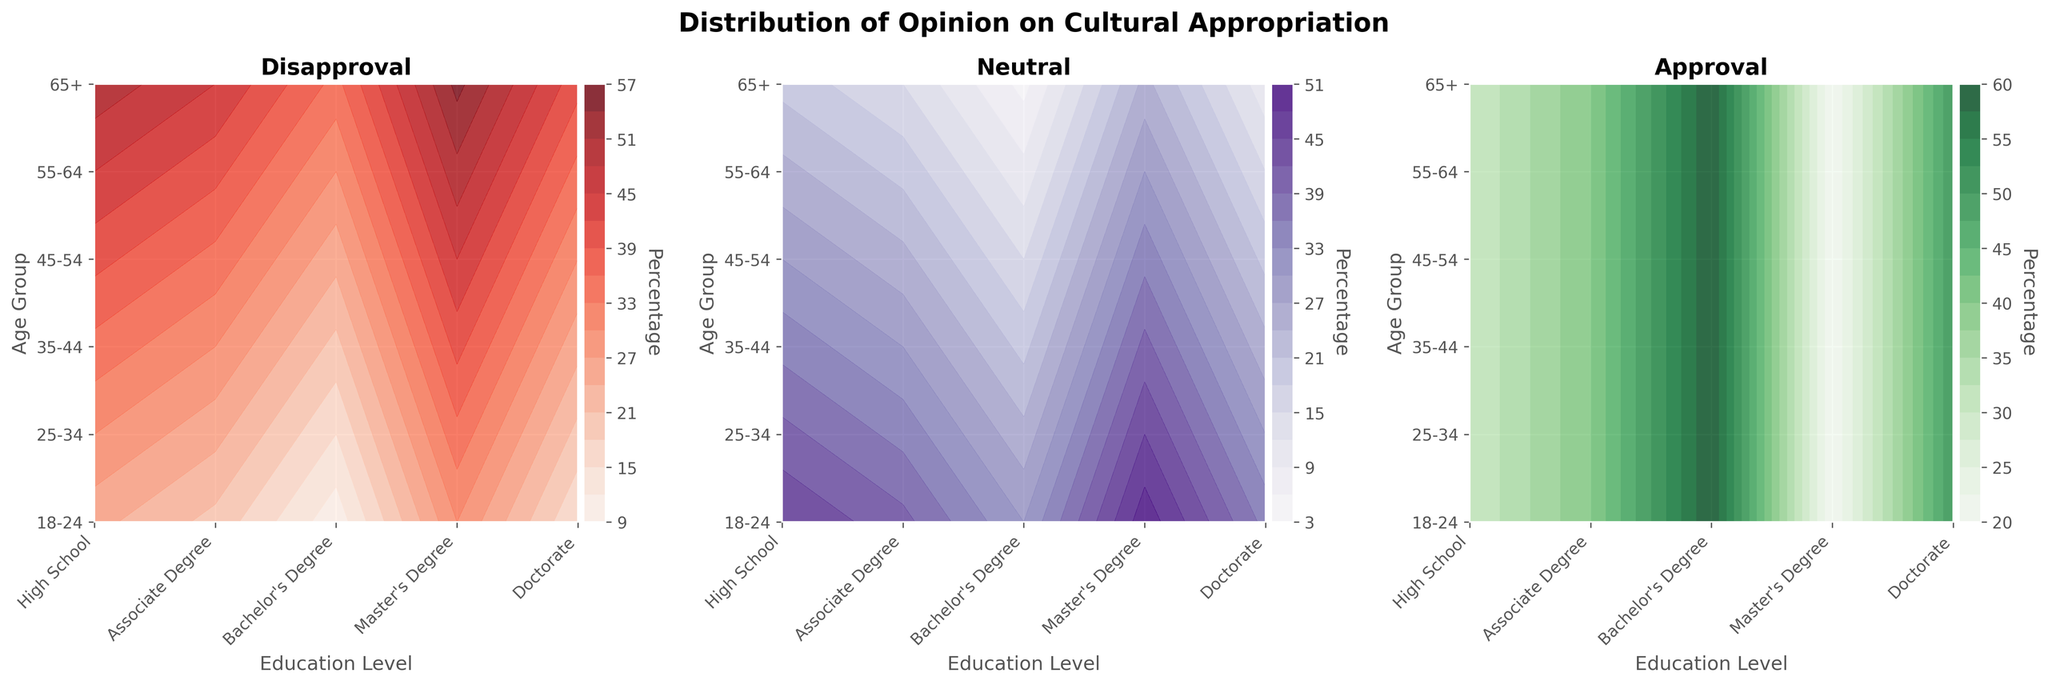What are the three opinions shown in the contour plots? The titles of the subplots indicate that there are three opinions: 'Disapproval', 'Neutral', and 'Approval'. You can see the titles at the top of each subplot.
Answer: Disapproval, Neutral, Approval Which age group and education level combination has the highest approval rate in the figures? In the 'Approval' subplot, the darkest green color represents the highest approval rate. For the age group 18-24 with a Doctorate, the approval rate is the highest, which you can determine as it has the darkest shade of green.
Answer: 18-24, Doctorate How does disapproval change with age for individuals with a High School education? Looking at the 'Disapproval' subplot, the oldest age group (65+) has the darkest red color, indicating the highest disapproval rate. The disapproval rate decreases as you move to younger age groups.
Answer: Disapproval increases with age Which education level generally has the lowest neutral opinion across all age groups? In the 'Neutral' subplot, the lightest purple color indicates the lowest neutral opinion. The Doctorate level consistently has the lightest colors across all age groups.
Answer: Doctorate What's the pattern of approval rate for Master's Degree holders across age groups? In the 'Approval' subplot, for the Master's Degree, the color becomes progressively darker from the oldest age group (65+) to the youngest (18-24), indicating increasing approval rates.
Answer: Approval increases with age For individuals aged 45-54, which education level is most associated with a neutral opinion? In the 'Neutral' subplot, for the age group 45-54, the brightest and darkest purple shades correlate with both High School and Associate Degrees, showing a high concentration of neutral opinions.
Answer: High School, Associate Degree Compare the disapproval rates between age groups 55-64 and 65+ for individuals with a Bachelor's Degree. In the 'Disapproval' subplot, for Bachelor's Degree holders, age group 65+ has a darker red color compared to 55-64, indicating a higher disapproval rate.
Answer: Disapproval is higher for 65+ What is the general trend in approval rates for individuals with a Bachelor's Degree across the age groups? Observing the 'Approval' subplot, for Bachelor's Degree holders, the green color becomes darker from older (65+ and 55-64) to younger (18-24) age groups, indicating increasing approval rates.
Answer: Approval increases with age Which education level within the age group 25-34 has the highest neutral opinion? In the 'Neutral' subplot for age group 25-34, the highest neutral opinion (darkest purple color) corresponds to High School education.
Answer: High School 